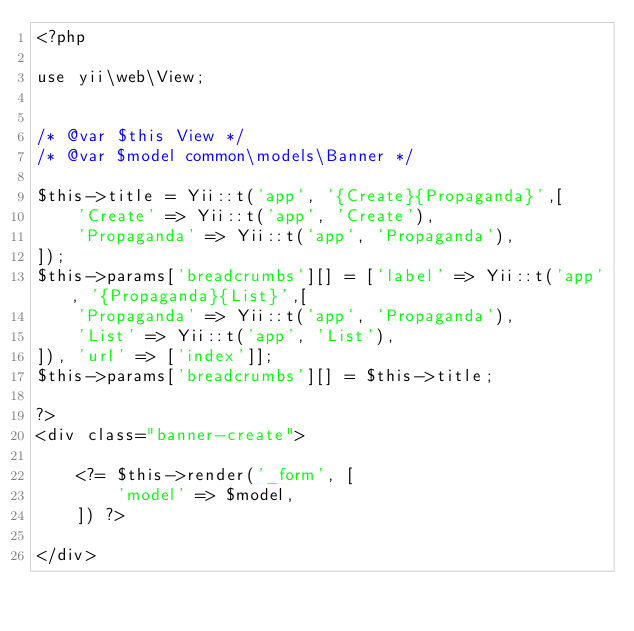<code> <loc_0><loc_0><loc_500><loc_500><_PHP_><?php

use yii\web\View;


/* @var $this View */
/* @var $model common\models\Banner */

$this->title = Yii::t('app', '{Create}{Propaganda}',[
    'Create' => Yii::t('app', 'Create'),
    'Propaganda' => Yii::t('app', 'Propaganda'),
]);
$this->params['breadcrumbs'][] = ['label' => Yii::t('app', '{Propaganda}{List}',[
    'Propaganda' => Yii::t('app', 'Propaganda'),
    'List' => Yii::t('app', 'List'),
]), 'url' => ['index']];
$this->params['breadcrumbs'][] = $this->title;

?>
<div class="banner-create">

    <?= $this->render('_form', [
        'model' => $model,
    ]) ?>

</div>
</code> 